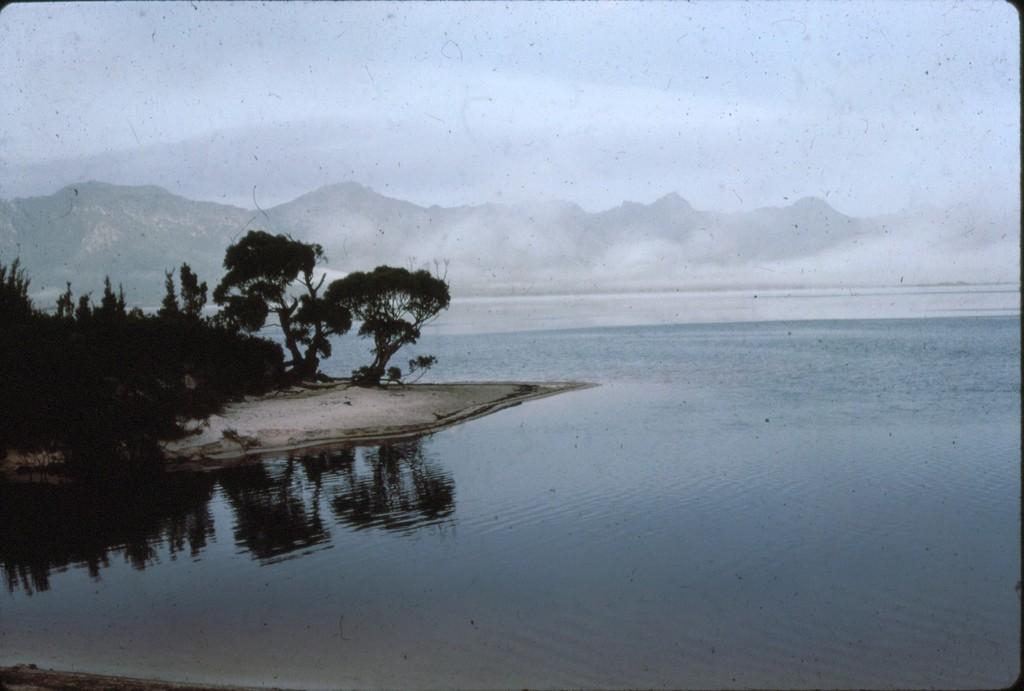What type of vegetation can be seen in the image? There are trees in the image. What natural feature is visible in the image? There is water visible in the image. What geographical feature can be seen in the distance? There are mountains in the image. What is visible above the trees and mountains? The sky is visible in the image. How many apples are hanging from the trees in the image? There are no apples visible in the image; only trees are present. Can you tell me who made the request for planes in the image? There is no mention of a request or planes in the image. 